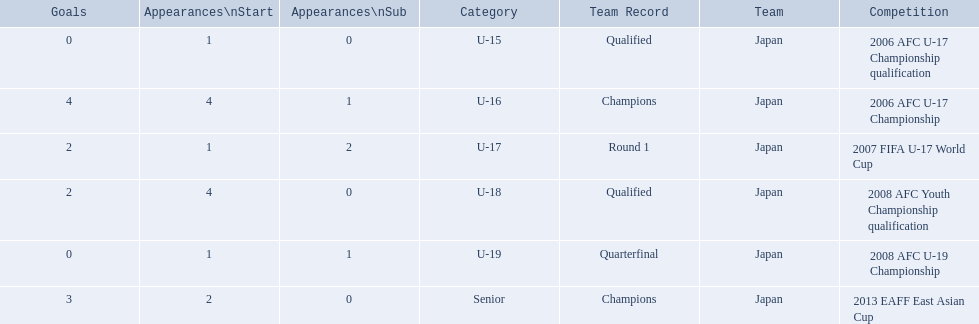Which competitions had champions team records? 2006 AFC U-17 Championship, 2013 EAFF East Asian Cup. Of these competitions, which one was in the senior category? 2013 EAFF East Asian Cup. 